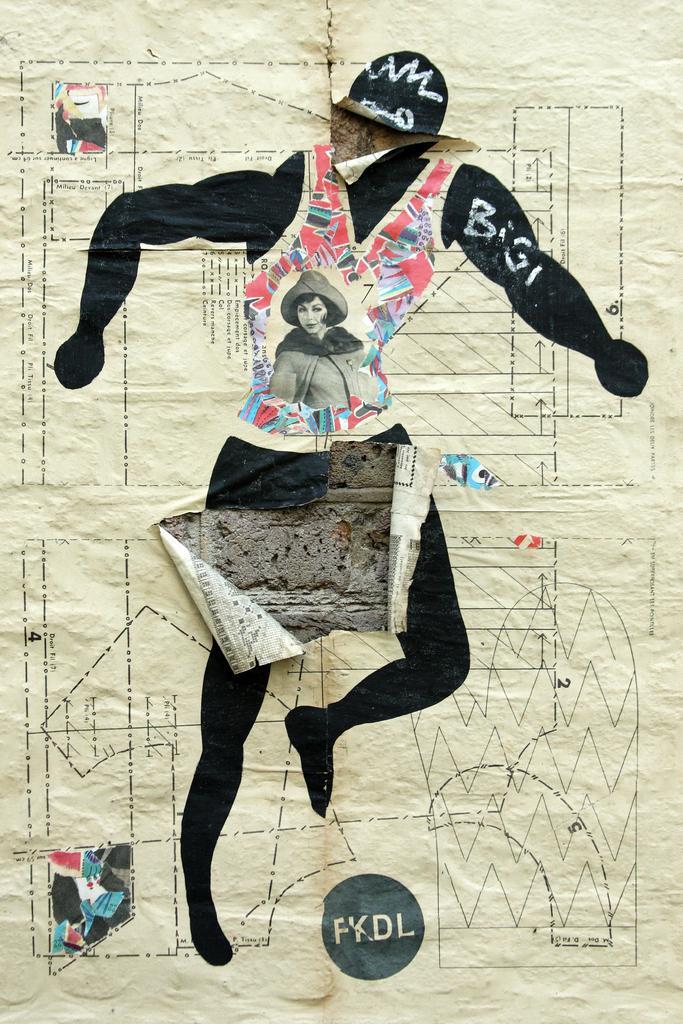In one or two sentences, can you explain what this image depicts? In this image I can see the person's image on the paper and the paper is attached to the grey color wall. 